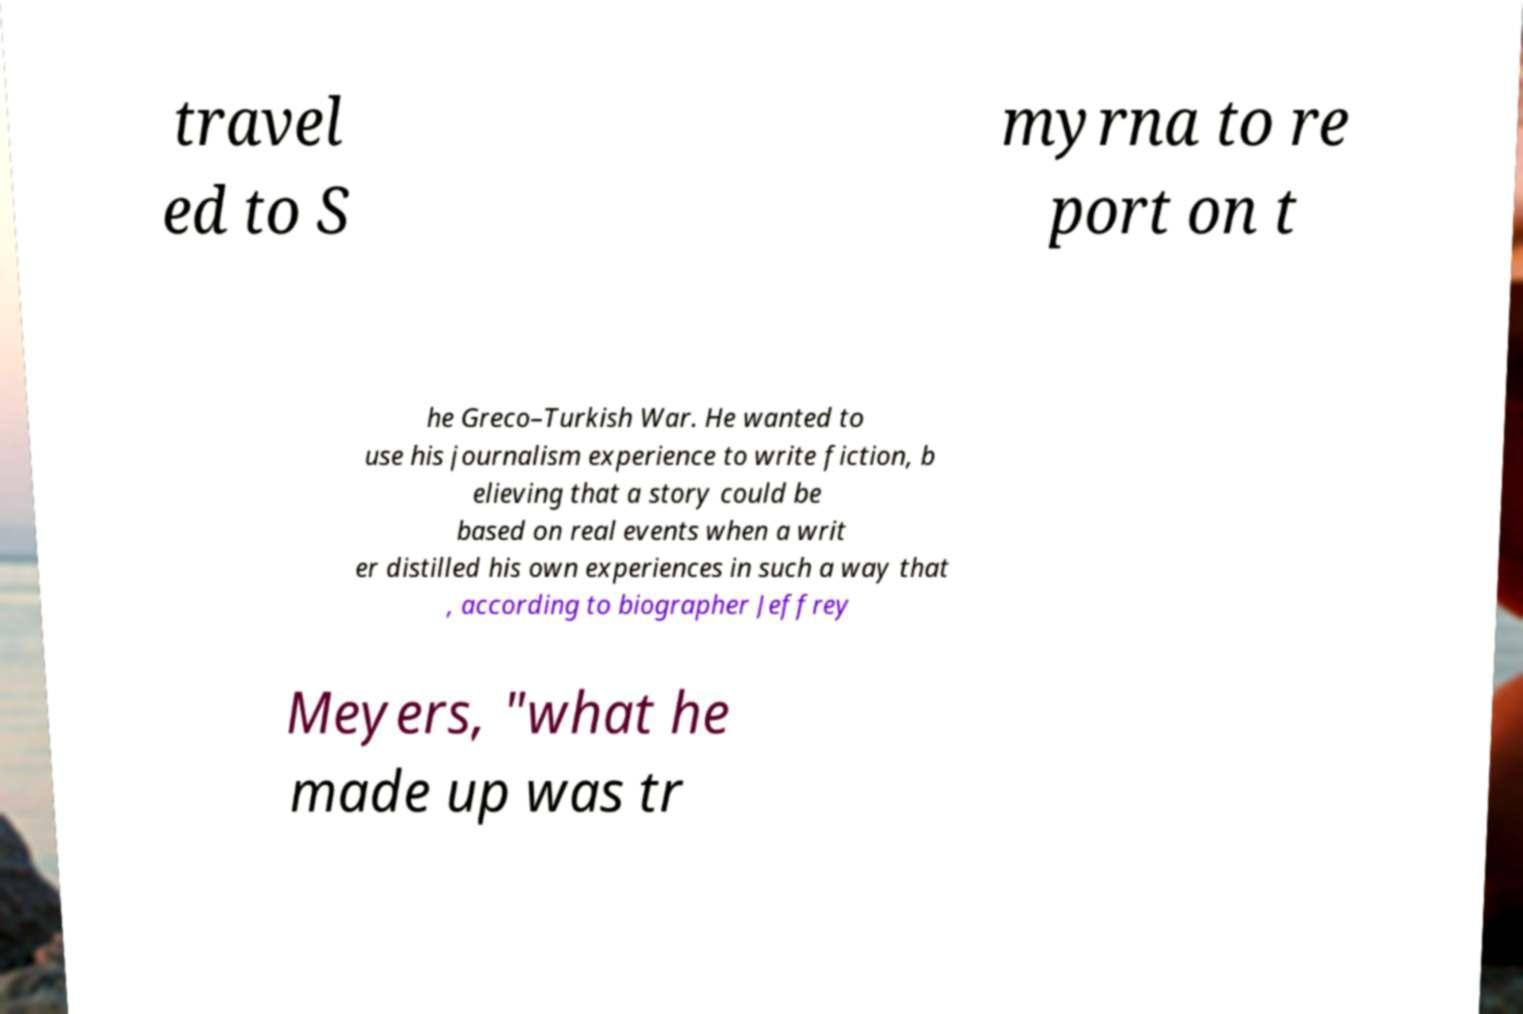Please read and relay the text visible in this image. What does it say? travel ed to S myrna to re port on t he Greco–Turkish War. He wanted to use his journalism experience to write fiction, b elieving that a story could be based on real events when a writ er distilled his own experiences in such a way that , according to biographer Jeffrey Meyers, "what he made up was tr 